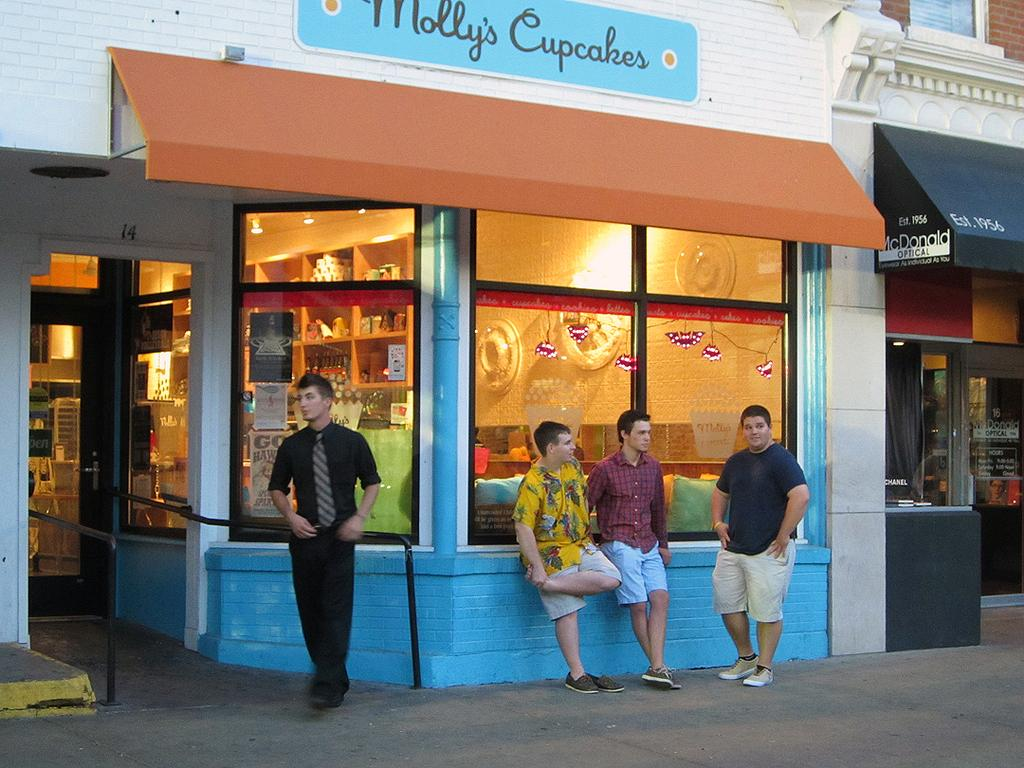What type of establishment is shown in the image? There is a store in the image. How are the items in the store displayed? Objects are arranged on shelves in the store. What can be seen outside the store in the image? There are persons standing on the road in the image. What safety feature is visible in the image? Railings are visible in the image. What type of window treatment is present in the image? Curtains are present in the image. What can be used to identify the store in the image? There is a name board in the image. What caption is written on the top of the image? There is no caption written on the top of the image; it is a photograph and not a text document. 